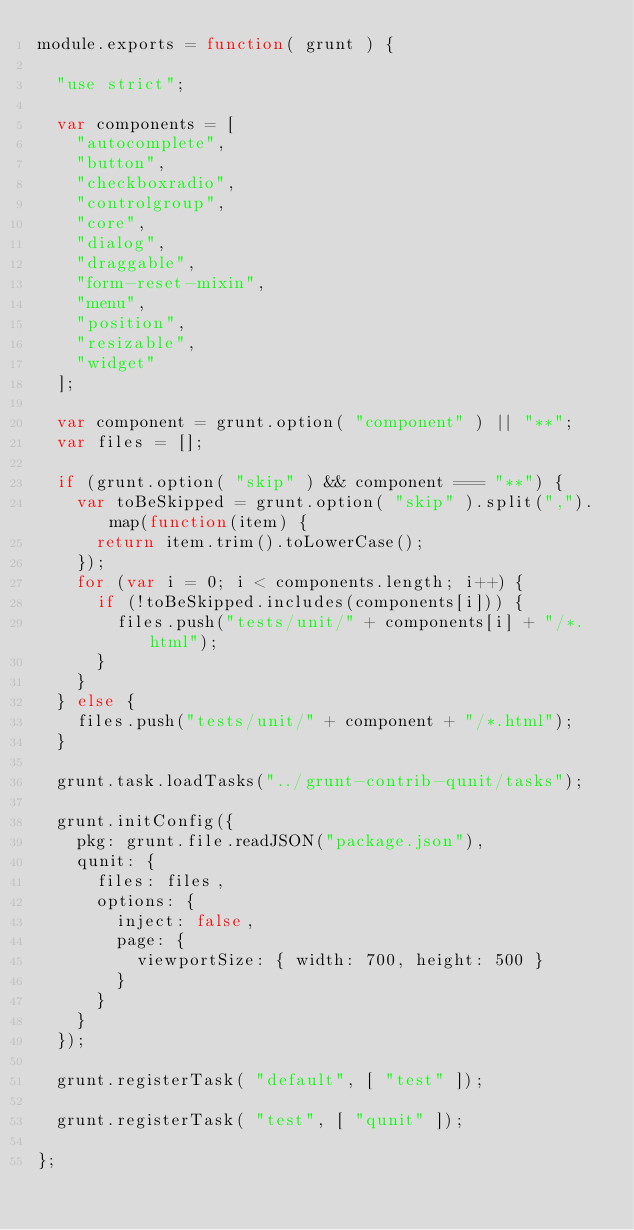Convert code to text. <code><loc_0><loc_0><loc_500><loc_500><_JavaScript_>module.exports = function( grunt ) {

	"use strict";

	var components = [
		"autocomplete",
		"button",
		"checkboxradio",
		"controlgroup",
		"core",
		"dialog",
		"draggable",
		"form-reset-mixin",
		"menu",
		"position",
		"resizable",
		"widget"
	];

	var component = grunt.option( "component" ) || "**";
	var files = [];

	if (grunt.option( "skip" ) && component === "**") {
		var toBeSkipped = grunt.option( "skip" ).split(",").map(function(item) {
			return item.trim().toLowerCase();
		});
		for (var i = 0; i < components.length; i++) {
			if (!toBeSkipped.includes(components[i])) {
				files.push("tests/unit/" + components[i] + "/*.html");
			}
		}
	} else {
		files.push("tests/unit/" + component + "/*.html");
	}

	grunt.task.loadTasks("../grunt-contrib-qunit/tasks");

	grunt.initConfig({
		pkg: grunt.file.readJSON("package.json"),
		qunit: {
			files: files,
			options: {
				inject: false,
				page: {
					viewportSize: { width: 700, height: 500 }
				}
			}
		}
	});

	grunt.registerTask( "default", [ "test" ]);

	grunt.registerTask( "test", [ "qunit" ]);

};
</code> 